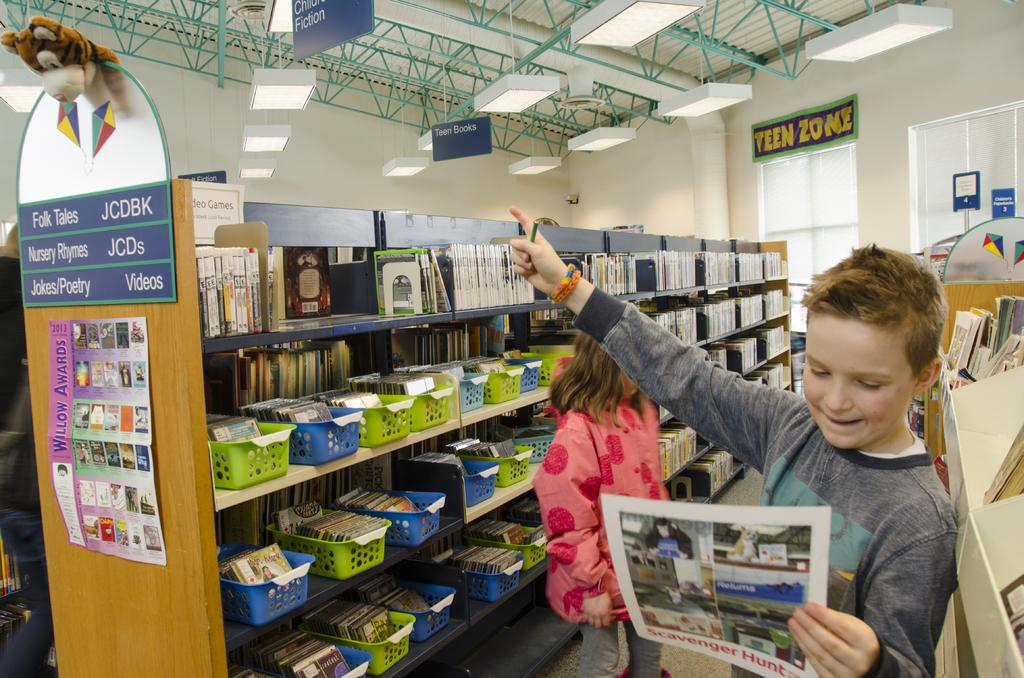<image>
Provide a brief description of the given image. Boy is pointing at a stuffed animal in the "Teen Zone". 